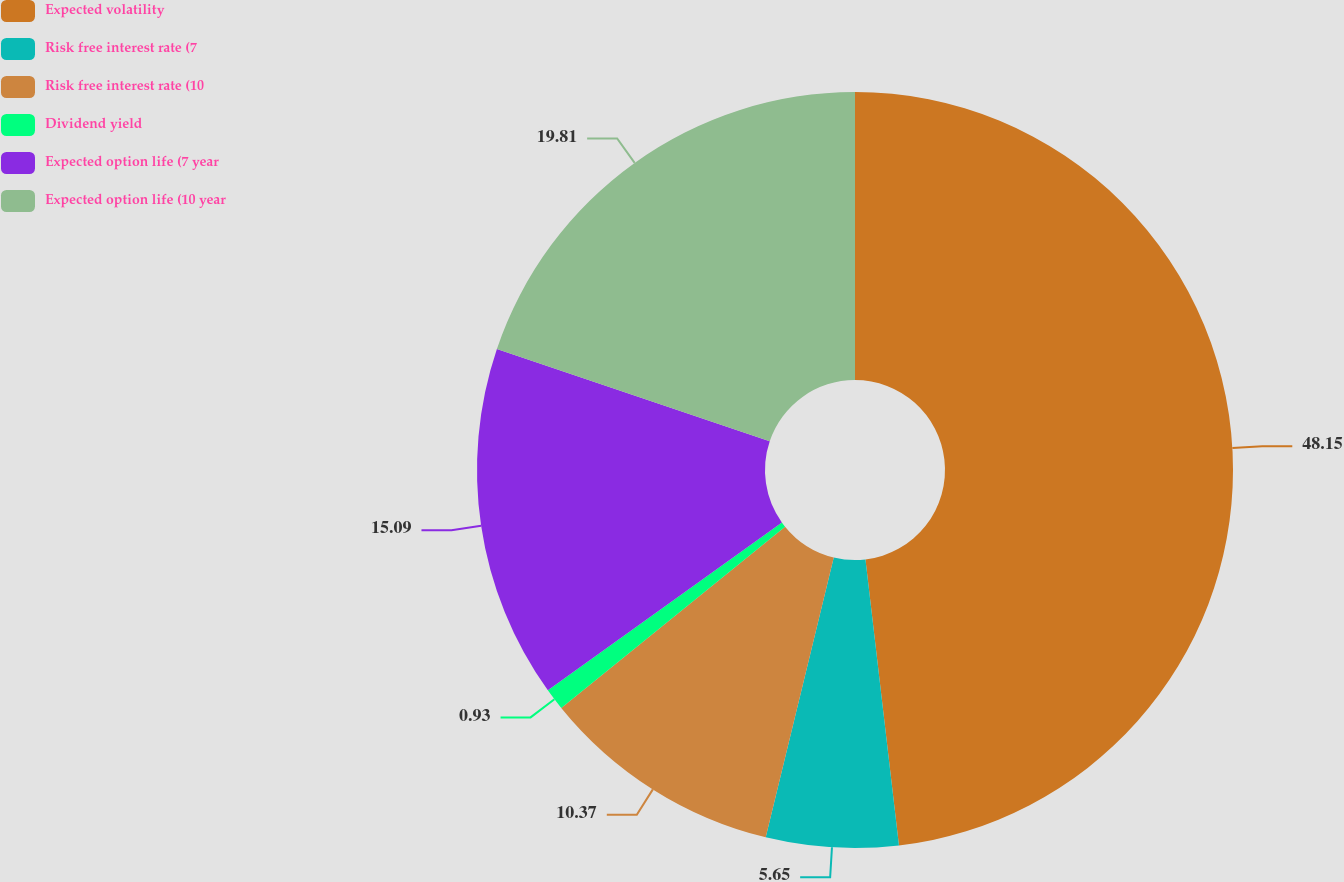Convert chart. <chart><loc_0><loc_0><loc_500><loc_500><pie_chart><fcel>Expected volatility<fcel>Risk free interest rate (7<fcel>Risk free interest rate (10<fcel>Dividend yield<fcel>Expected option life (7 year<fcel>Expected option life (10 year<nl><fcel>48.14%<fcel>5.65%<fcel>10.37%<fcel>0.93%<fcel>15.09%<fcel>19.81%<nl></chart> 